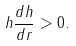<formula> <loc_0><loc_0><loc_500><loc_500>h \frac { d h } { d r } > 0 .</formula> 